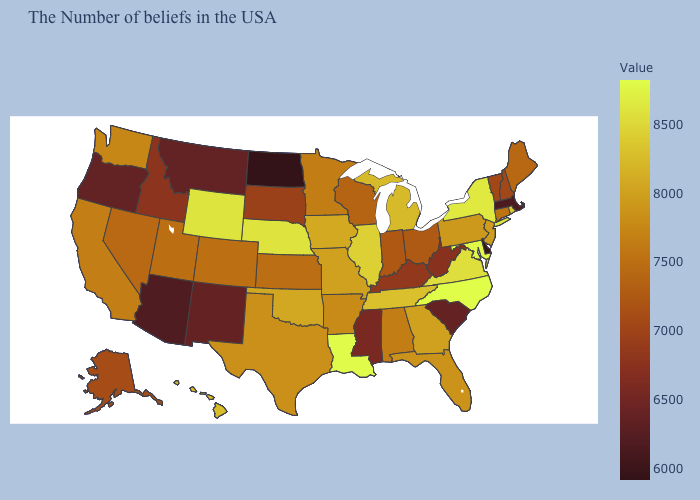Does New York have the highest value in the Northeast?
Short answer required. Yes. Which states hav the highest value in the MidWest?
Be succinct. Nebraska. Does Rhode Island have a lower value than California?
Quick response, please. No. Does Montana have the highest value in the West?
Answer briefly. No. Among the states that border New Hampshire , which have the lowest value?
Keep it brief. Massachusetts. Which states hav the highest value in the West?
Keep it brief. Wyoming. Does North Dakota have the lowest value in the USA?
Quick response, please. Yes. Which states have the lowest value in the USA?
Short answer required. North Dakota. 